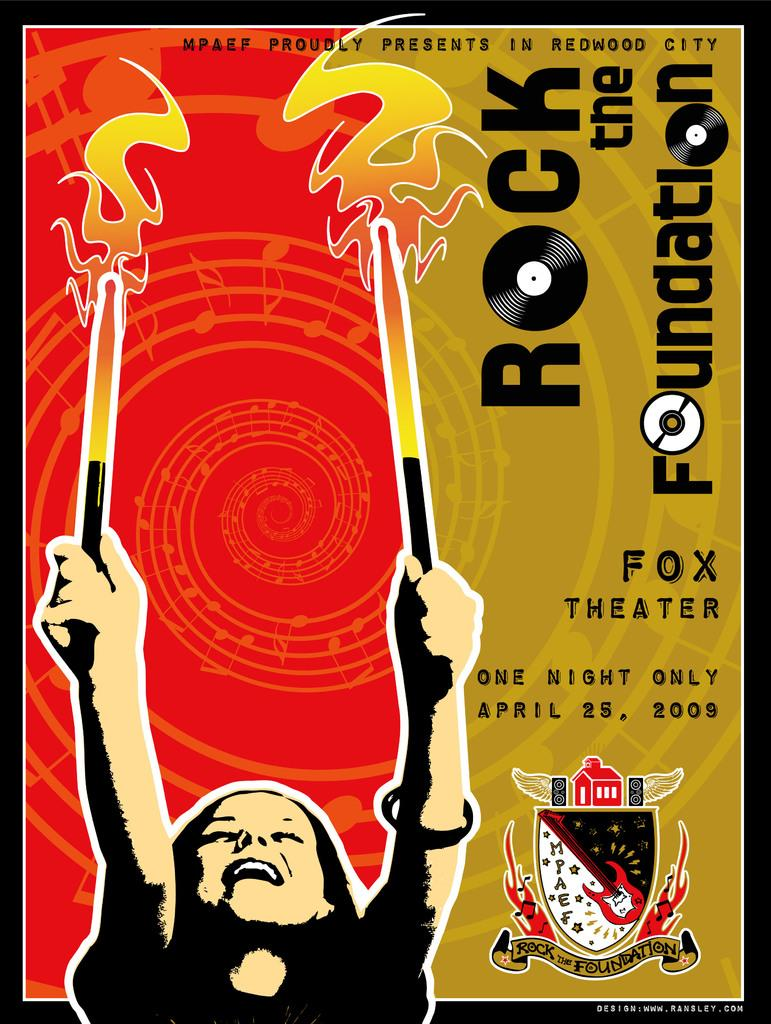Provide a one-sentence caption for the provided image. poster for a rock and roll concert at the fox theater. 